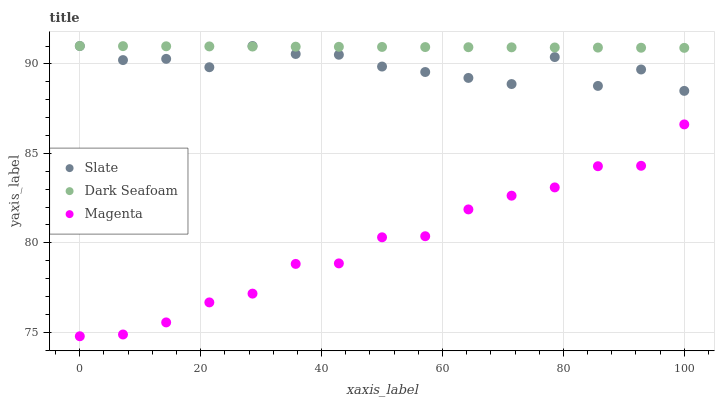Does Magenta have the minimum area under the curve?
Answer yes or no. Yes. Does Dark Seafoam have the maximum area under the curve?
Answer yes or no. Yes. Does Dark Seafoam have the minimum area under the curve?
Answer yes or no. No. Does Magenta have the maximum area under the curve?
Answer yes or no. No. Is Dark Seafoam the smoothest?
Answer yes or no. Yes. Is Slate the roughest?
Answer yes or no. Yes. Is Magenta the smoothest?
Answer yes or no. No. Is Magenta the roughest?
Answer yes or no. No. Does Magenta have the lowest value?
Answer yes or no. Yes. Does Dark Seafoam have the lowest value?
Answer yes or no. No. Does Dark Seafoam have the highest value?
Answer yes or no. Yes. Does Magenta have the highest value?
Answer yes or no. No. Is Magenta less than Slate?
Answer yes or no. Yes. Is Dark Seafoam greater than Magenta?
Answer yes or no. Yes. Does Dark Seafoam intersect Slate?
Answer yes or no. Yes. Is Dark Seafoam less than Slate?
Answer yes or no. No. Is Dark Seafoam greater than Slate?
Answer yes or no. No. Does Magenta intersect Slate?
Answer yes or no. No. 